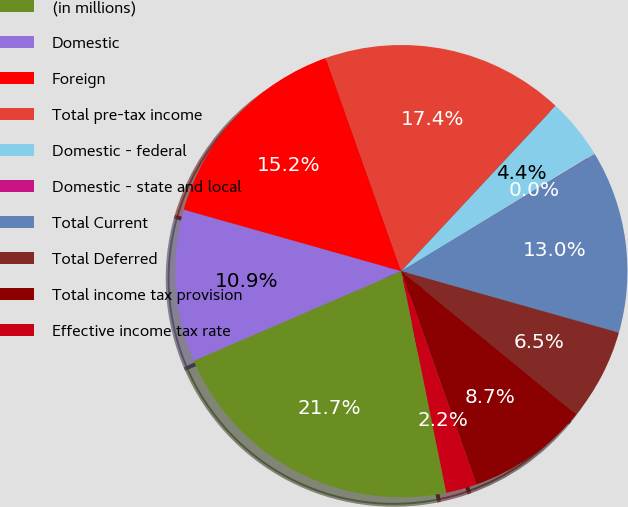<chart> <loc_0><loc_0><loc_500><loc_500><pie_chart><fcel>(in millions)<fcel>Domestic<fcel>Foreign<fcel>Total pre-tax income<fcel>Domestic - federal<fcel>Domestic - state and local<fcel>Total Current<fcel>Total Deferred<fcel>Total income tax provision<fcel>Effective income tax rate<nl><fcel>21.7%<fcel>10.87%<fcel>15.2%<fcel>17.37%<fcel>4.37%<fcel>0.03%<fcel>13.03%<fcel>6.53%<fcel>8.7%<fcel>2.2%<nl></chart> 